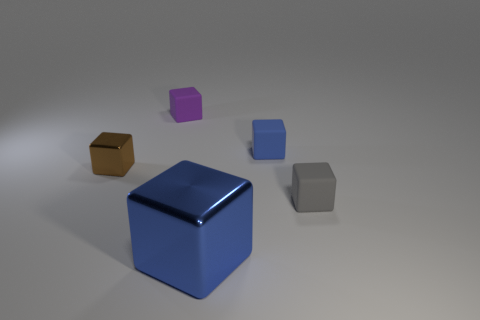Subtract all large shiny blocks. How many blocks are left? 4 Subtract all green cylinders. How many blue blocks are left? 2 Subtract 2 blocks. How many blocks are left? 3 Subtract all gray cubes. How many cubes are left? 4 Add 3 tiny metal blocks. How many objects exist? 8 Subtract all yellow cubes. Subtract all purple spheres. How many cubes are left? 5 Add 2 large cubes. How many large cubes are left? 3 Add 5 large blue spheres. How many large blue spheres exist? 5 Subtract 0 cyan blocks. How many objects are left? 5 Subtract all small cubes. Subtract all tiny brown objects. How many objects are left? 0 